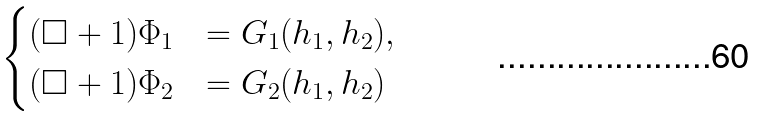Convert formula to latex. <formula><loc_0><loc_0><loc_500><loc_500>\begin{cases} ( \square + 1 ) \Phi _ { 1 } & = G _ { 1 } ( h _ { 1 } , h _ { 2 } ) , \\ ( \square + 1 ) \Phi _ { 2 } & = G _ { 2 } ( h _ { 1 } , h _ { 2 } ) \end{cases}</formula> 